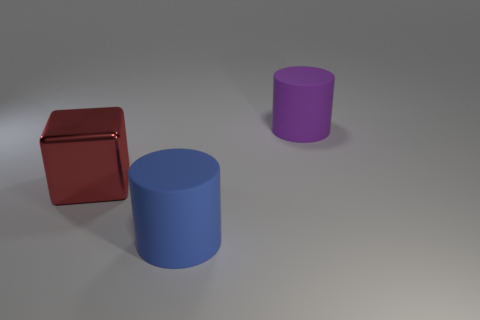How many small objects are cylinders or blocks? In the image, there are two objects that can be classified as cylinders and one object that is a block. Therefore, there are a total of three small objects that are either cylinders or blocks. 